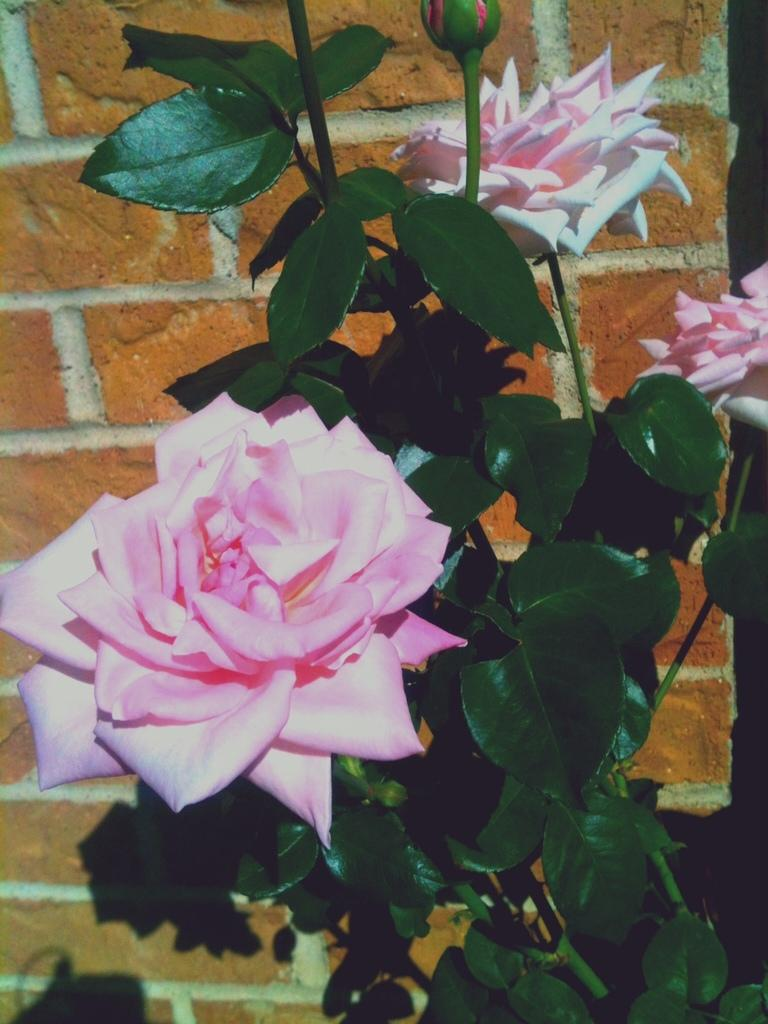What type of plant life is visible in the image? There are green leaves and pink flowers with stems in the image. Can you describe the stage of growth for one of the plants in the image? There is a bud in the image, which indicates a stage of growth before full bloom. What is the background of the image? There is a wall in the image. What colors are present on the wall? The wall has a white and orange color. What type of insect can be seen crawling on the leaf in the image? There are no insects visible in the image; it only features green leaves, pink flowers, a bud, and a wall. 